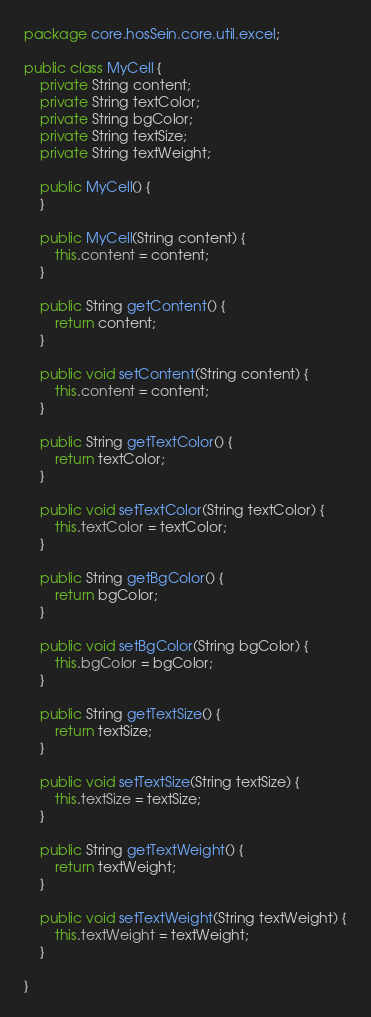Convert code to text. <code><loc_0><loc_0><loc_500><loc_500><_Java_>package core.hosSein.core.util.excel;

public class MyCell {
    private String content;
    private String textColor;
    private String bgColor;
    private String textSize;
    private String textWeight;

    public MyCell() {
    }

    public MyCell(String content) {
        this.content = content;
    }

    public String getContent() {
        return content;
    }

    public void setContent(String content) {
        this.content = content;
    }

    public String getTextColor() {
        return textColor;
    }

    public void setTextColor(String textColor) {
        this.textColor = textColor;
    }

    public String getBgColor() {
        return bgColor;
    }

    public void setBgColor(String bgColor) {
        this.bgColor = bgColor;
    }

    public String getTextSize() {
        return textSize;
    }

    public void setTextSize(String textSize) {
        this.textSize = textSize;
    }

    public String getTextWeight() {
        return textWeight;
    }

    public void setTextWeight(String textWeight) {
        this.textWeight = textWeight;
    }

}
</code> 